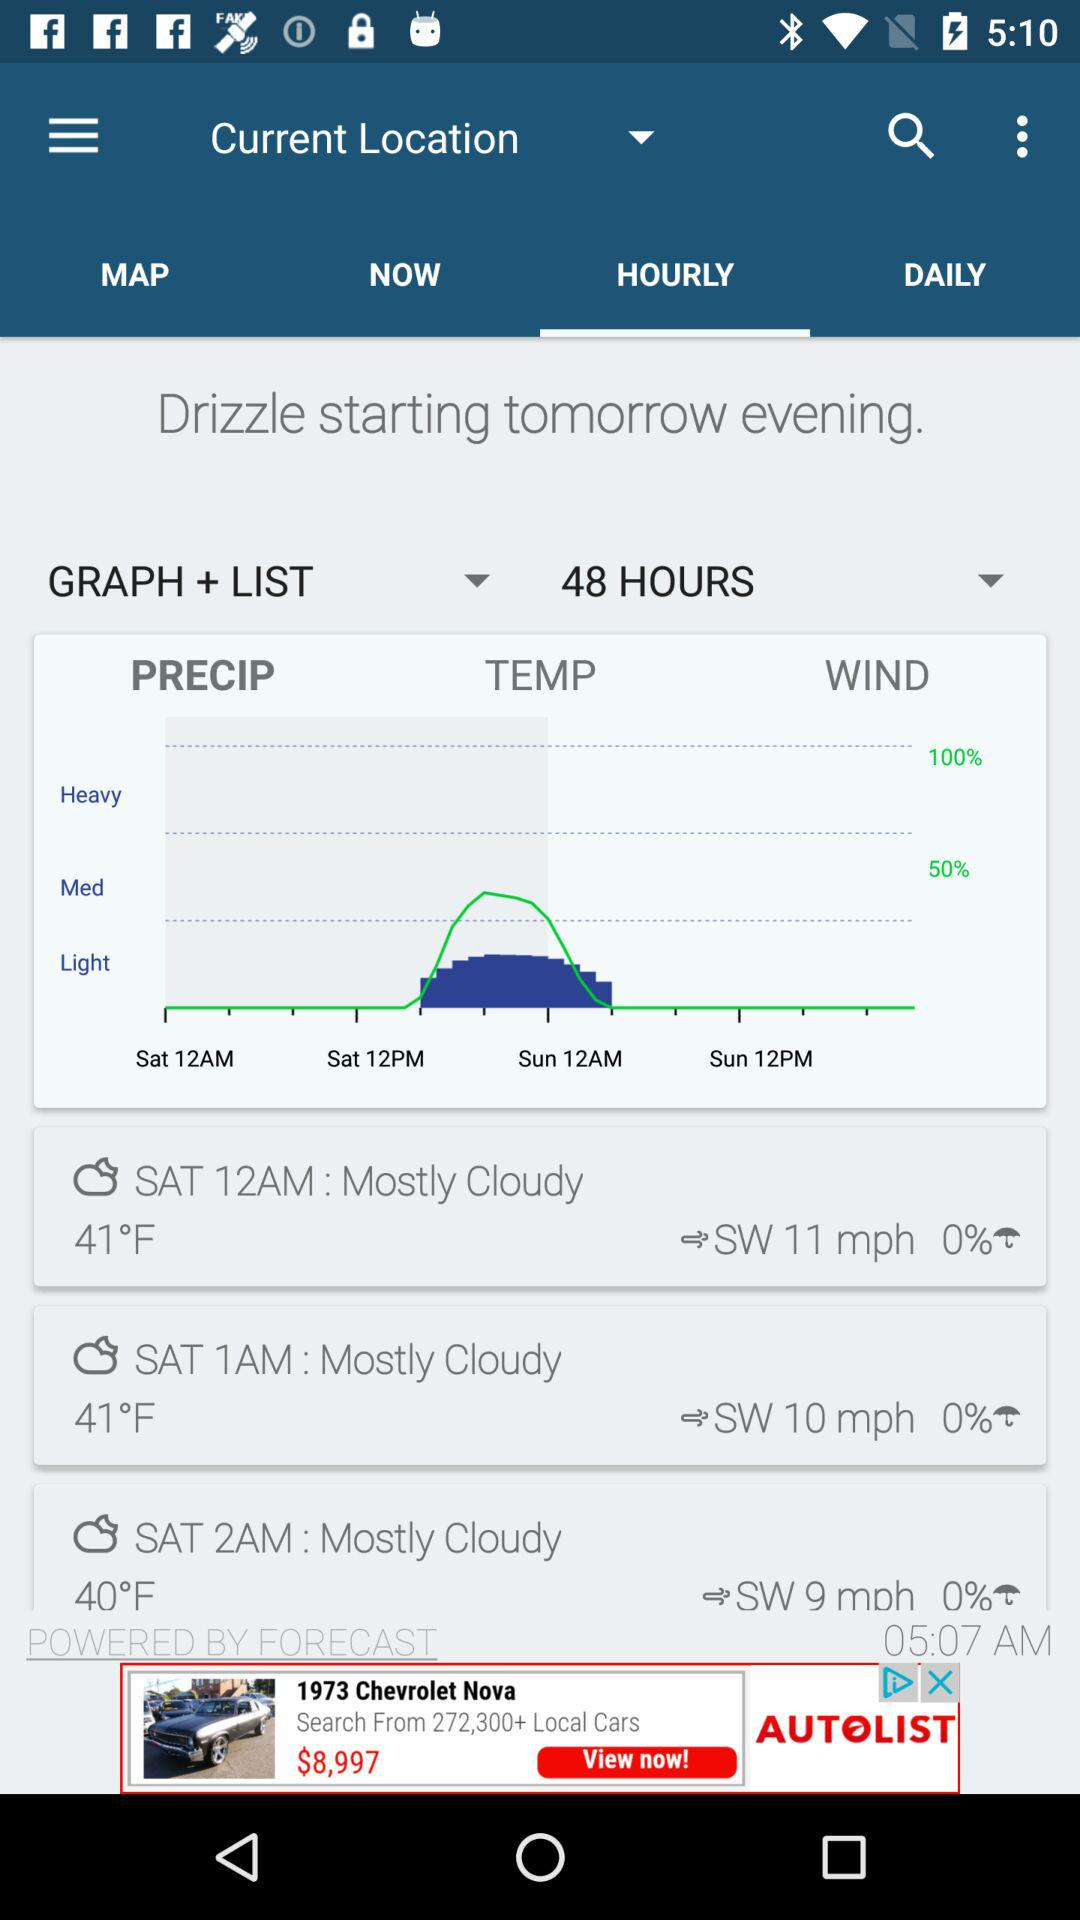What is the date for 40 degree temperature?
When the provided information is insufficient, respond with <no answer>. <no answer> 